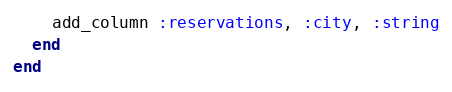Convert code to text. <code><loc_0><loc_0><loc_500><loc_500><_Ruby_>    add_column :reservations, :city, :string
  end
end
</code> 